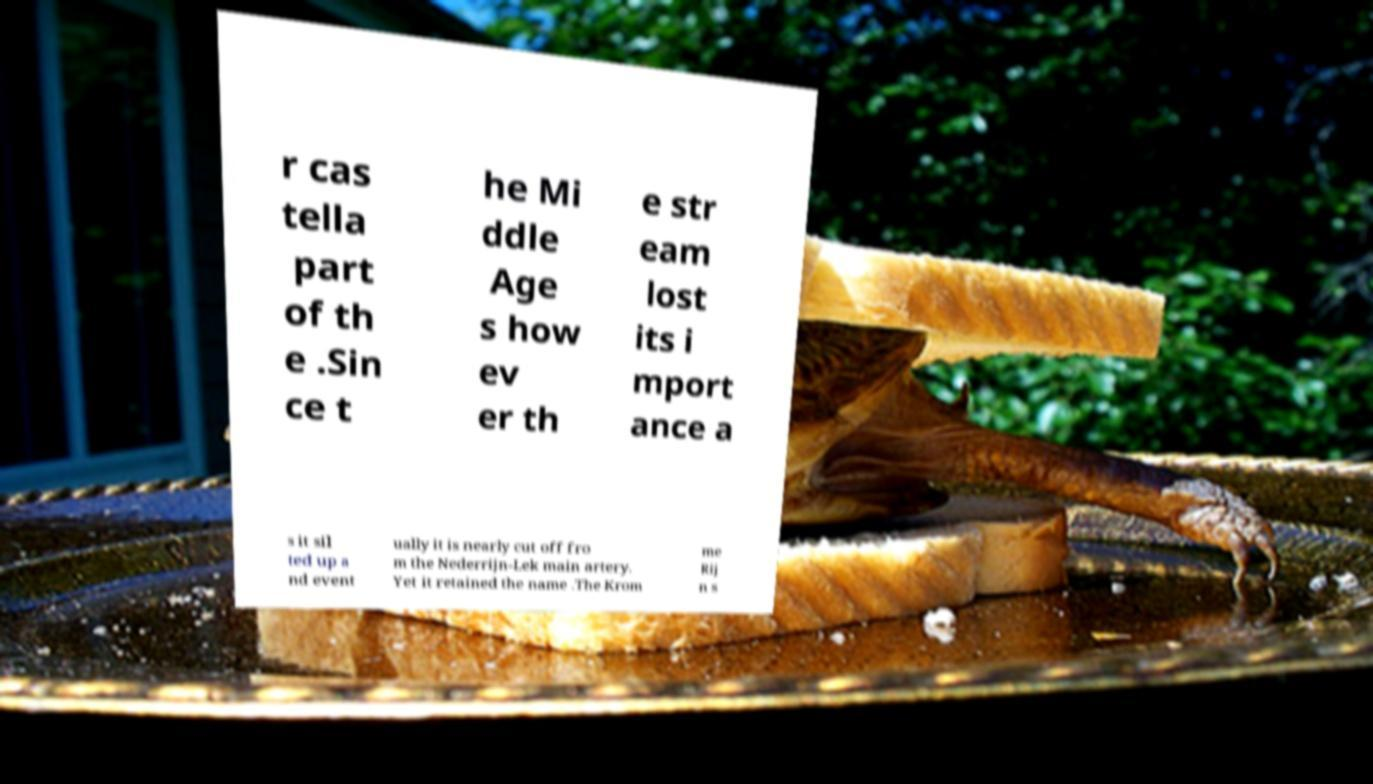Could you assist in decoding the text presented in this image and type it out clearly? r cas tella part of th e .Sin ce t he Mi ddle Age s how ev er th e str eam lost its i mport ance a s it sil ted up a nd event ually it is nearly cut off fro m the Nederrijn-Lek main artery. Yet it retained the name .The Krom me Rij n s 